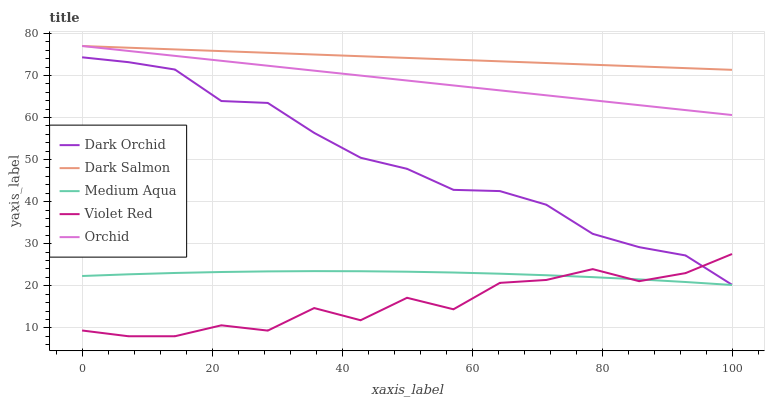Does Violet Red have the minimum area under the curve?
Answer yes or no. Yes. Does Dark Salmon have the maximum area under the curve?
Answer yes or no. Yes. Does Medium Aqua have the minimum area under the curve?
Answer yes or no. No. Does Medium Aqua have the maximum area under the curve?
Answer yes or no. No. Is Dark Salmon the smoothest?
Answer yes or no. Yes. Is Violet Red the roughest?
Answer yes or no. Yes. Is Medium Aqua the smoothest?
Answer yes or no. No. Is Medium Aqua the roughest?
Answer yes or no. No. Does Medium Aqua have the lowest value?
Answer yes or no. No. Does Medium Aqua have the highest value?
Answer yes or no. No. Is Medium Aqua less than Dark Orchid?
Answer yes or no. Yes. Is Orchid greater than Dark Orchid?
Answer yes or no. Yes. Does Medium Aqua intersect Dark Orchid?
Answer yes or no. No. 